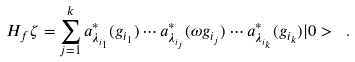Convert formula to latex. <formula><loc_0><loc_0><loc_500><loc_500>H _ { f } \zeta = \sum _ { j = 1 } ^ { k } a ^ { * } _ { \lambda _ { i _ { 1 } } } ( g _ { i _ { 1 } } ) \cdots a ^ { * } _ { \lambda _ { i _ { j } } } ( \omega g _ { i _ { j } } ) \cdots a ^ { * } _ { \lambda _ { i _ { k } } } ( g _ { i _ { k } } ) | 0 > \ .</formula> 